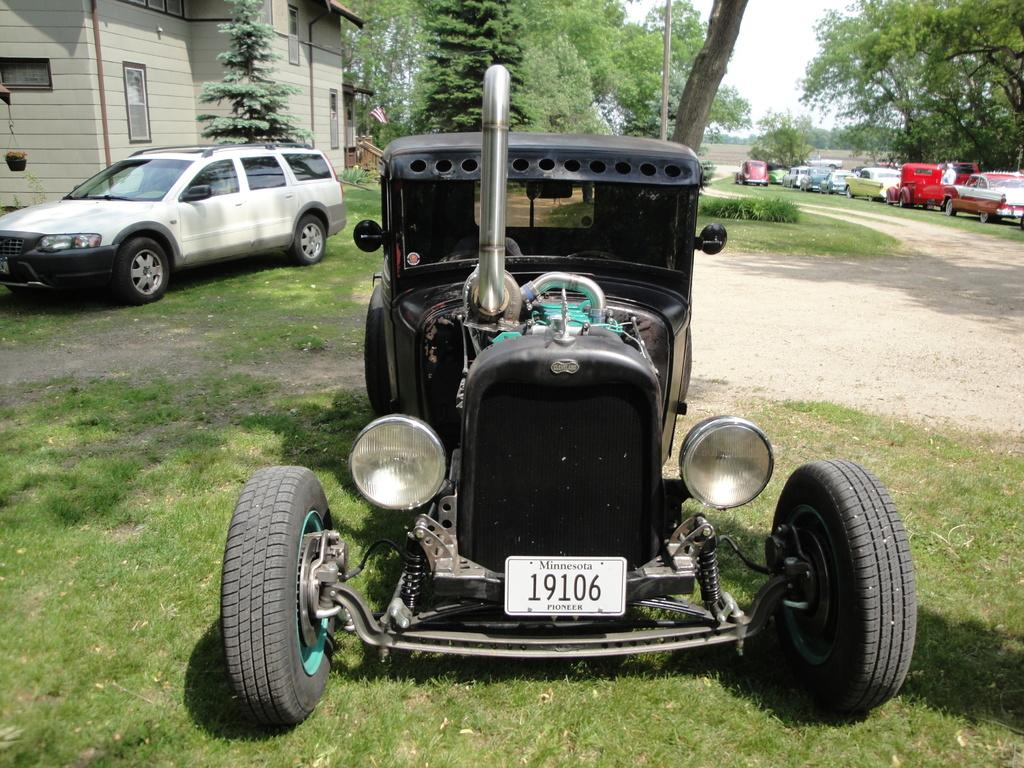What is located on the grassy land in the image? There is a vehicle on the grassy land. What can be seen in the background of the image? There are trees, a building, a flag, a car, and the sky visible in the background of the image. Where are the cars located in the image? There are cars on the right side of the image. What type of poison is being used to conduct a science experiment in the image? There is no indication of a science experiment or poison in the image. How many planes can be seen in the image? There are no planes present in the image. 